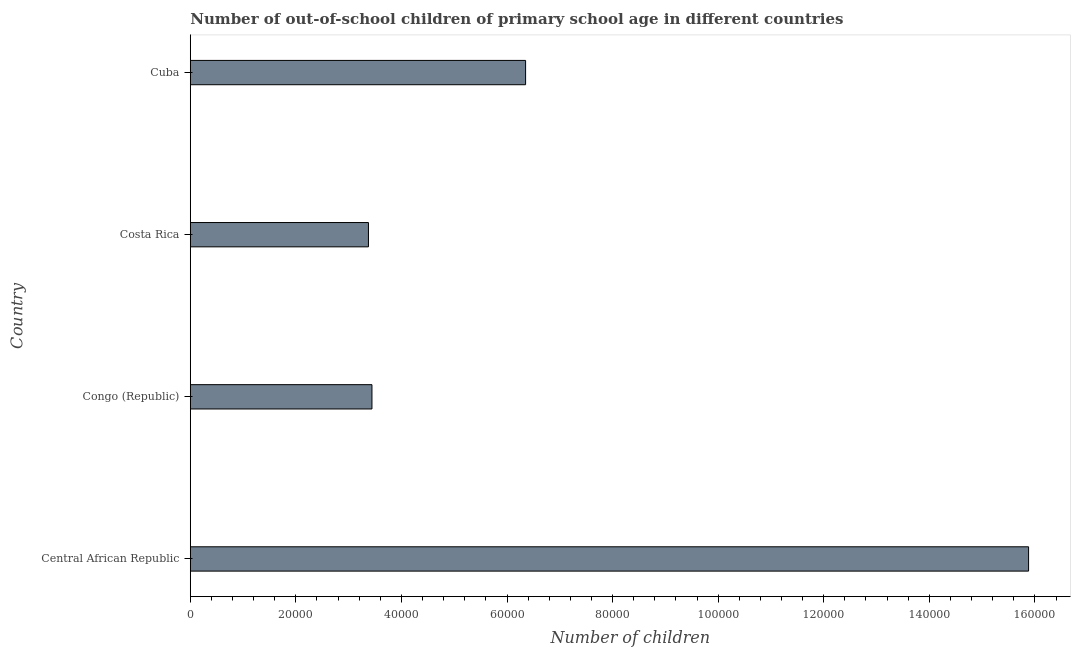What is the title of the graph?
Provide a short and direct response. Number of out-of-school children of primary school age in different countries. What is the label or title of the X-axis?
Offer a very short reply. Number of children. What is the number of out-of-school children in Cuba?
Provide a succinct answer. 6.35e+04. Across all countries, what is the maximum number of out-of-school children?
Your answer should be very brief. 1.59e+05. Across all countries, what is the minimum number of out-of-school children?
Your answer should be very brief. 3.38e+04. In which country was the number of out-of-school children maximum?
Your answer should be very brief. Central African Republic. What is the sum of the number of out-of-school children?
Offer a very short reply. 2.90e+05. What is the difference between the number of out-of-school children in Central African Republic and Congo (Republic)?
Offer a very short reply. 1.24e+05. What is the average number of out-of-school children per country?
Ensure brevity in your answer.  7.26e+04. What is the median number of out-of-school children?
Your answer should be compact. 4.90e+04. In how many countries, is the number of out-of-school children greater than 44000 ?
Offer a very short reply. 2. What is the ratio of the number of out-of-school children in Costa Rica to that in Cuba?
Ensure brevity in your answer.  0.53. Is the difference between the number of out-of-school children in Central African Republic and Cuba greater than the difference between any two countries?
Make the answer very short. No. What is the difference between the highest and the second highest number of out-of-school children?
Keep it short and to the point. 9.53e+04. Is the sum of the number of out-of-school children in Central African Republic and Congo (Republic) greater than the maximum number of out-of-school children across all countries?
Provide a short and direct response. Yes. What is the difference between the highest and the lowest number of out-of-school children?
Keep it short and to the point. 1.25e+05. In how many countries, is the number of out-of-school children greater than the average number of out-of-school children taken over all countries?
Offer a terse response. 1. How many countries are there in the graph?
Your response must be concise. 4. What is the difference between two consecutive major ticks on the X-axis?
Offer a terse response. 2.00e+04. What is the Number of children of Central African Republic?
Provide a short and direct response. 1.59e+05. What is the Number of children in Congo (Republic)?
Provide a succinct answer. 3.44e+04. What is the Number of children in Costa Rica?
Ensure brevity in your answer.  3.38e+04. What is the Number of children in Cuba?
Provide a succinct answer. 6.35e+04. What is the difference between the Number of children in Central African Republic and Congo (Republic)?
Give a very brief answer. 1.24e+05. What is the difference between the Number of children in Central African Republic and Costa Rica?
Offer a very short reply. 1.25e+05. What is the difference between the Number of children in Central African Republic and Cuba?
Provide a succinct answer. 9.53e+04. What is the difference between the Number of children in Congo (Republic) and Costa Rica?
Provide a succinct answer. 662. What is the difference between the Number of children in Congo (Republic) and Cuba?
Provide a succinct answer. -2.91e+04. What is the difference between the Number of children in Costa Rica and Cuba?
Your answer should be compact. -2.98e+04. What is the ratio of the Number of children in Central African Republic to that in Congo (Republic)?
Keep it short and to the point. 4.62. What is the ratio of the Number of children in Central African Republic to that in Costa Rica?
Your answer should be compact. 4.71. What is the ratio of the Number of children in Central African Republic to that in Cuba?
Give a very brief answer. 2.5. What is the ratio of the Number of children in Congo (Republic) to that in Cuba?
Give a very brief answer. 0.54. What is the ratio of the Number of children in Costa Rica to that in Cuba?
Provide a succinct answer. 0.53. 